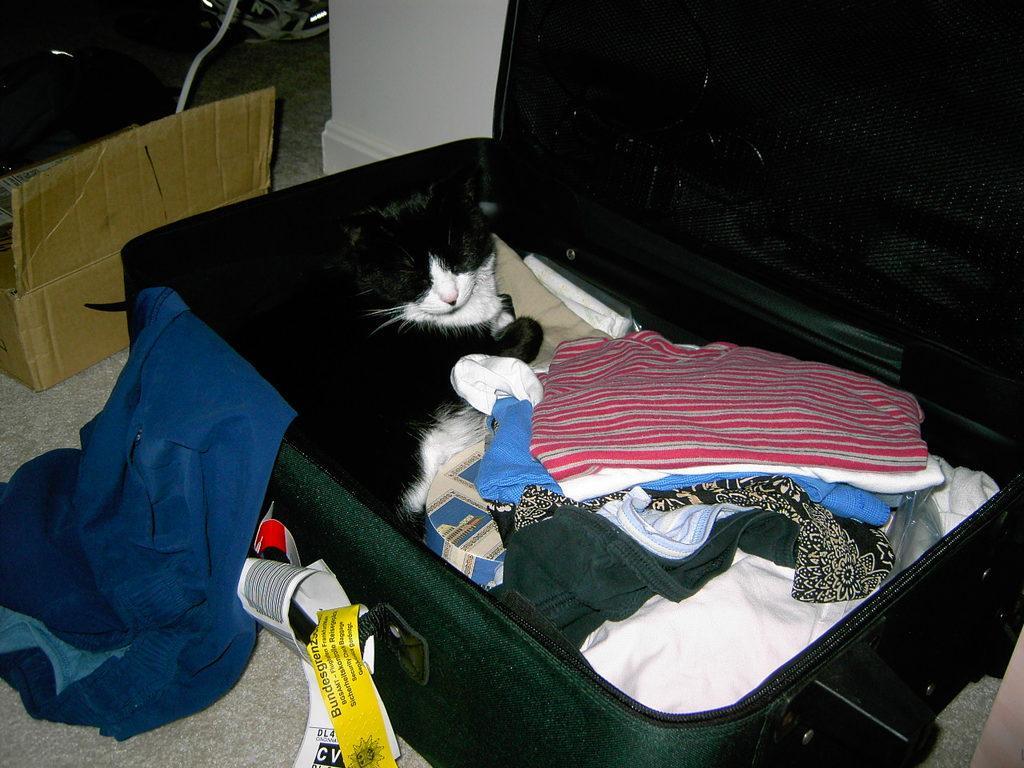How would you summarize this image in a sentence or two? In this Image I see a cat which is lying on the clothes which are in the suitcase, I can also see few tags over here. 